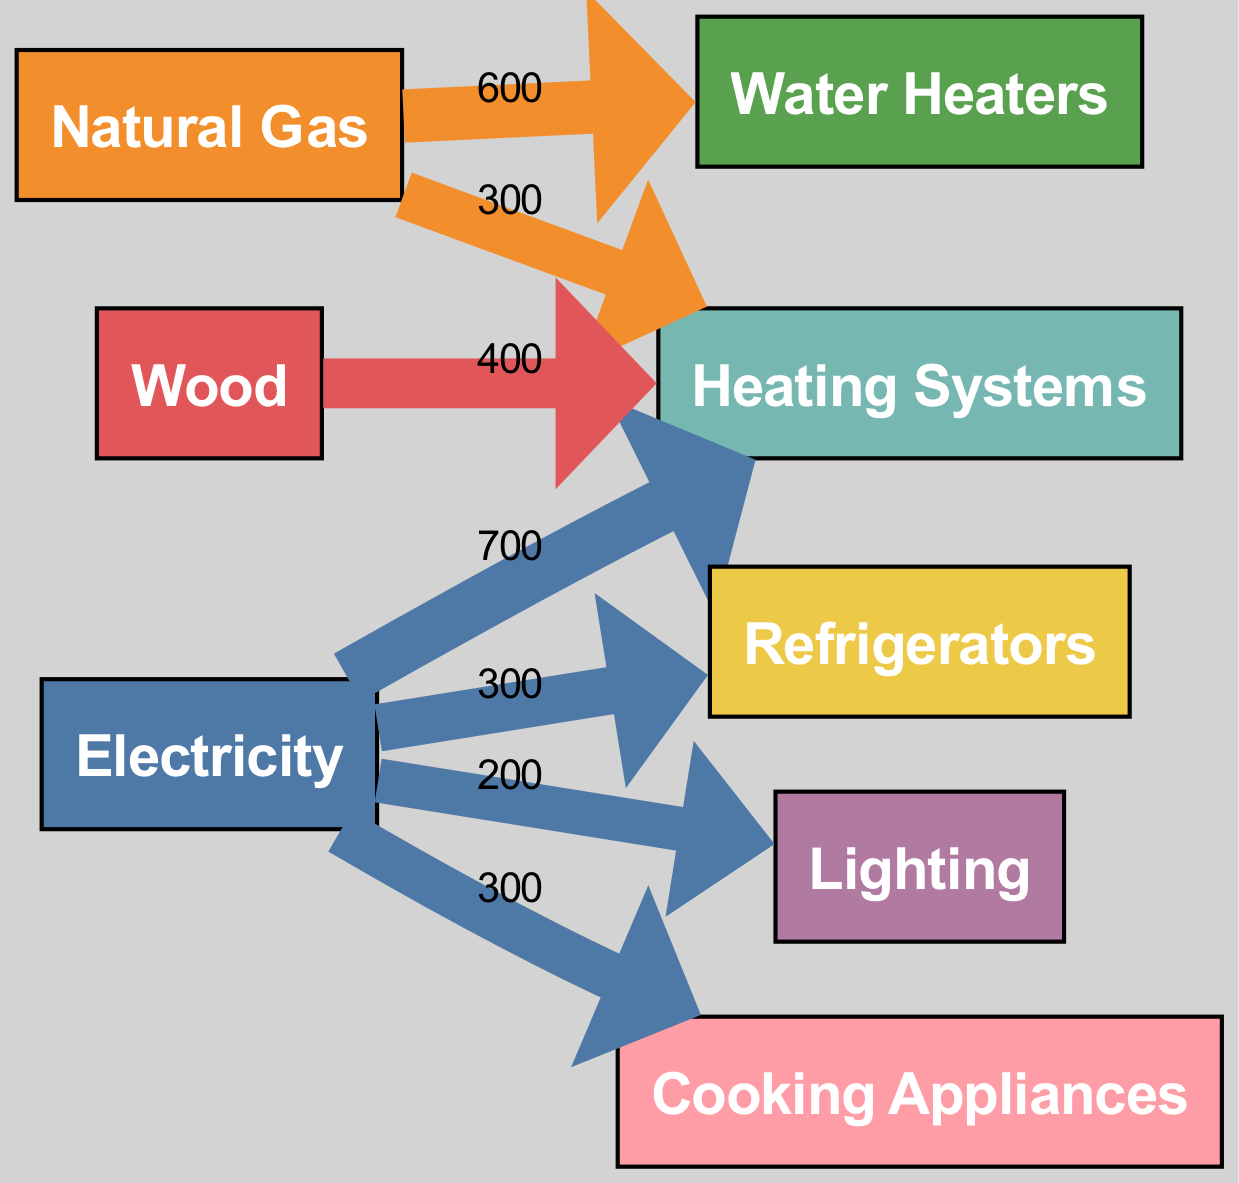What is the total energy consumption from electricity? The diagram lists electricity as a source with a total value of 1200.
Answer: 1200 Which appliance consumes the most energy? Looking at the appliance types, heating systems have the highest value of 1000.
Answer: Heating Systems How much energy does natural gas contribute to heating systems? The flow data indicates that natural gas contributes 300 units to heating systems.
Answer: 300 What is the total energy consumption from wood? The diagram shows wood as a source with a total value of 400.
Answer: 400 How many different energy sources are shown in the diagram? The diagram features three energy sources: electricity, natural gas, and wood, thus totaling three.
Answer: 3 Which appliance type has the least energy consumption, and what is the value? The diagram displays refrigerators with a value of 300, which is the lowest among the appliances.
Answer: Refrigerators, 300 What is the total energy consumed by water heaters? The flow data lists natural gas contributing 600 to water heaters, hence that is the total.
Answer: 600 How is the energy from electricity distributed among different appliances? Examining the flow data, electricity flows to heating systems (700), refrigerators (300), lighting (200), and cooking appliances (300).
Answer: Heating Systems, 700; Refrigerators, 300; Lighting, 200; Cooking Appliances, 300 Which energy source has the highest contribution to heating systems? The diagram shows that electricity contributes 700 and wood contributes 400 to heating systems. The highest is from electricity with 700.
Answer: Electricity, 700 